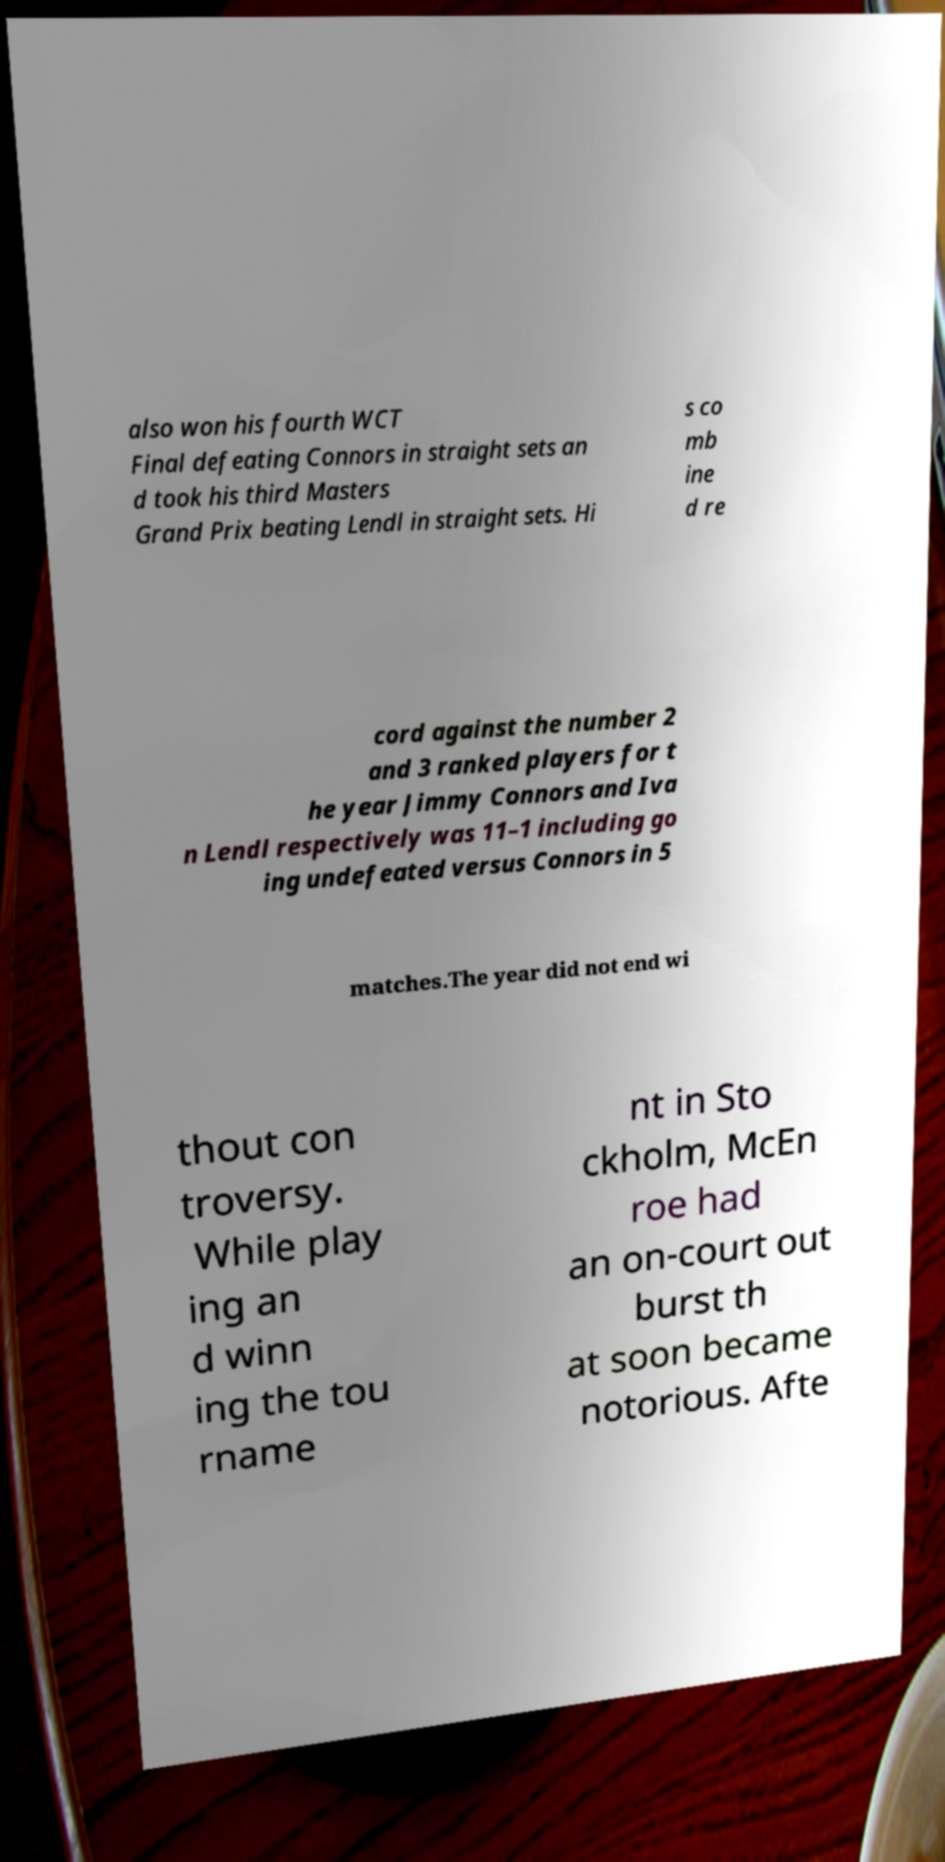There's text embedded in this image that I need extracted. Can you transcribe it verbatim? also won his fourth WCT Final defeating Connors in straight sets an d took his third Masters Grand Prix beating Lendl in straight sets. Hi s co mb ine d re cord against the number 2 and 3 ranked players for t he year Jimmy Connors and Iva n Lendl respectively was 11–1 including go ing undefeated versus Connors in 5 matches.The year did not end wi thout con troversy. While play ing an d winn ing the tou rname nt in Sto ckholm, McEn roe had an on-court out burst th at soon became notorious. Afte 